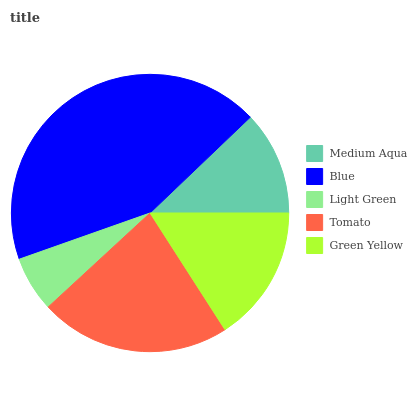Is Light Green the minimum?
Answer yes or no. Yes. Is Blue the maximum?
Answer yes or no. Yes. Is Blue the minimum?
Answer yes or no. No. Is Light Green the maximum?
Answer yes or no. No. Is Blue greater than Light Green?
Answer yes or no. Yes. Is Light Green less than Blue?
Answer yes or no. Yes. Is Light Green greater than Blue?
Answer yes or no. No. Is Blue less than Light Green?
Answer yes or no. No. Is Green Yellow the high median?
Answer yes or no. Yes. Is Green Yellow the low median?
Answer yes or no. Yes. Is Tomato the high median?
Answer yes or no. No. Is Tomato the low median?
Answer yes or no. No. 